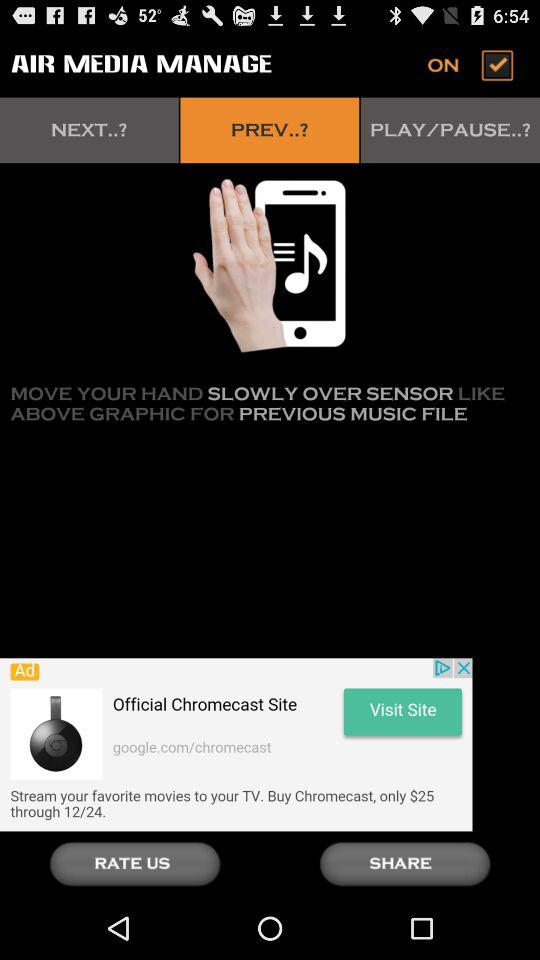What is the name of the application? The name of the application is "AIR MEDIA MANAGE". 